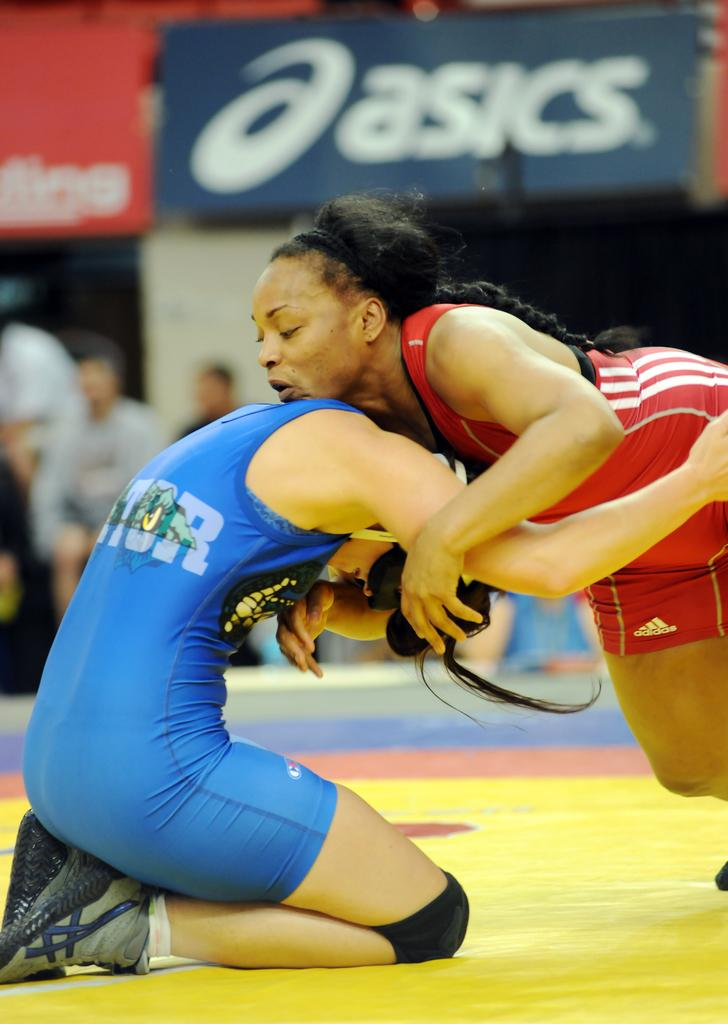Provide a one-sentence caption for the provided image. one of the sponsors of the game is asics. 